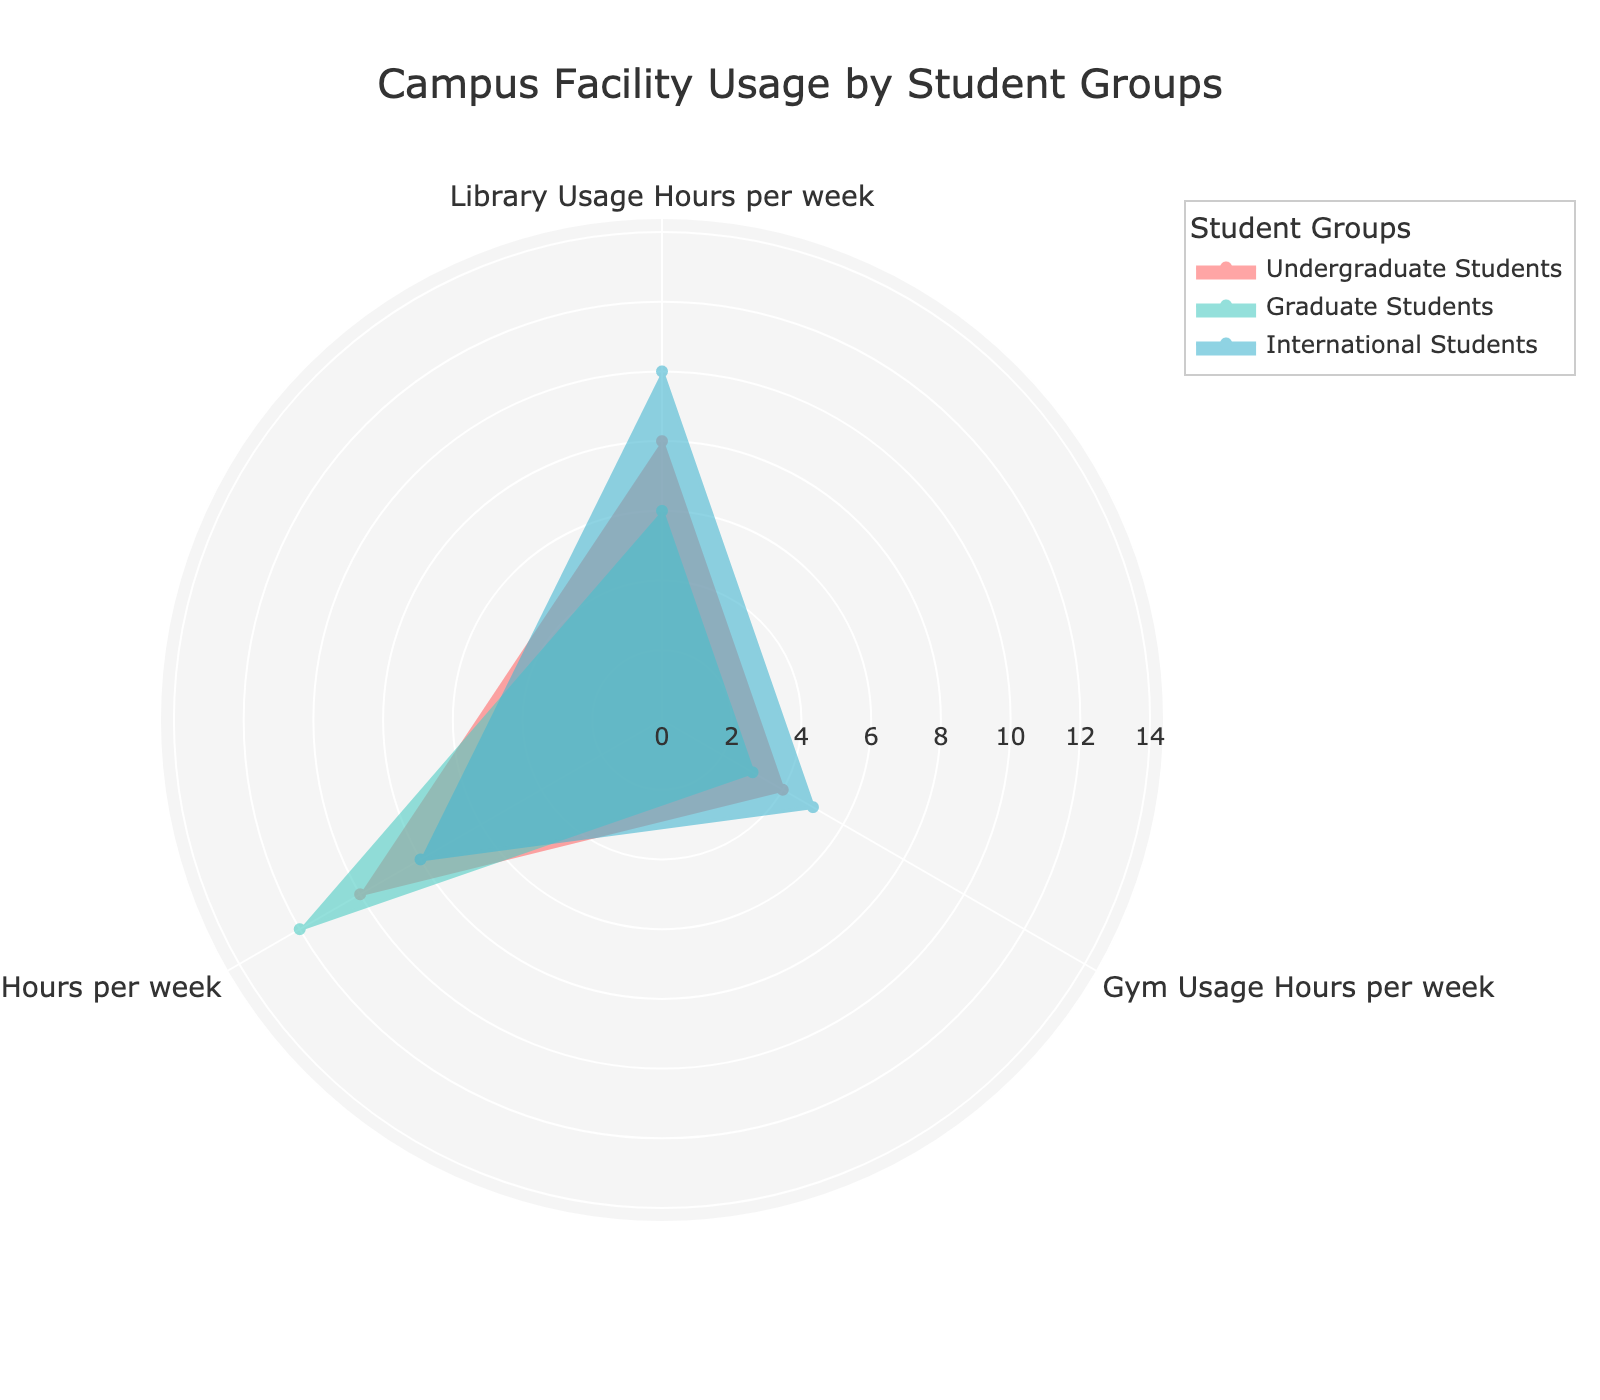What's the title of the figure? The title is usually placed at the top of the figure and is clearly visible in larger font size to provide an overview of the data being represented.
Answer: Campus Facility Usage by Student Groups Which student group uses the library the most per week? Compare the library usage hours for each group by looking at the corresponding section of the rose chart to identify the highest value. The graph shows "International Students" with the longest bar in the library usage category.
Answer: International Students What’s the median usage of study rooms per week across all groups shown? To find the median, list the study room usage hours in numerical order and select the middle value. The values are 8, 10, and 12, so the median is the middle value: 10.
Answer: 10 Which group has the least variation in facility usage across the three categories? Look at the overall lengths of the three segments (library, gym, and study rooms) for each group and find the one with the most consistent segment lengths. "Graduate Students" have relatively more uniform usage values of 6, 3, and 12.
Answer: Graduate Students How does the gym usage of International Students compare to that of First-Generation Students? Check the gym usage values on the rose chart for both groups and compare them. International Students use the gym for 5 hours, while First-Generation Students use it for 2 hours.
Answer: International Students use the gym more What is the total usage of the library across all groups in hours? Sum the library usage hours for Undergraduate Students, Graduate Students, and International Students. The values are 8 + 6 + 10 = 24 hours.
Answer: 24 hours Is the study room usage higher for Undergraduate Students or International Students? Compare the study room usage values from the chart. Undergraduate Students have 10 hours, while International Students have 8 hours.
Answer: Undergraduate Students Which student group has the highest total usage for all three facilities combined? Sum the usage hours for each group, and find the highest value. - Undergraduate Students: 8 + 4 + 10 = 22 - Graduate Students: 6 + 3 + 12 = 21 - International Students: 10 + 5 + 8 = 23 The highest total usage is by International Students.
Answer: International Students What is the average gym usage per week for the groups shown? Calculate the average gym usage by summing the gym usage hours (4 + 3 + 5) and dividing by the number of groups (3). The average is (4 + 3 + 5) / 3 = 4 hours.
Answer: 4 hours Is there any group whose study room usage is less than its library usage? Compare the study room and library usage values for each group. International Students use 8 hours for study rooms and 10 hours for the library, so their study room usage is less.
Answer: Yes, International Students 